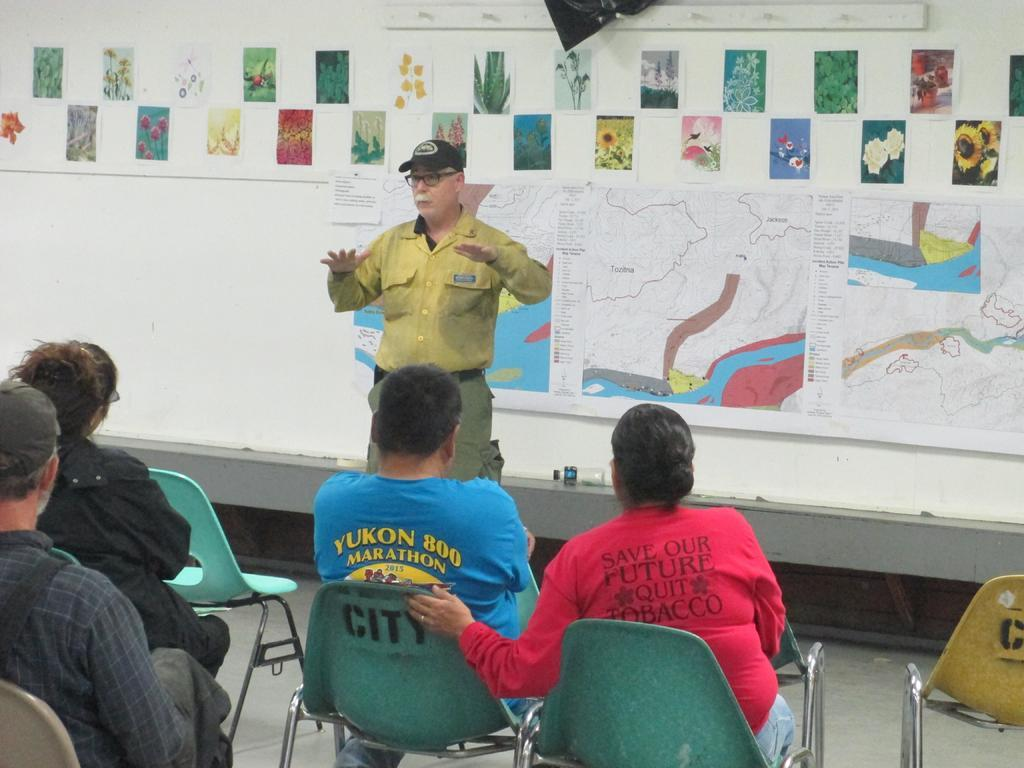Where is the setting of the image? The image is inside a room. What are the people in the room doing? There are people sitting on chairs in the room. What can be seen on the walls of the room? There are pictures and posters on the walls. Can you describe the man standing in the room? The man is wearing a yellow shirt and a cap. What question is the man asking in the image? There is no indication in the image that the man is asking a question. What type of laborer is depicted in the image? There is no laborer present in the image; it features people sitting on chairs and a man standing in a room. 